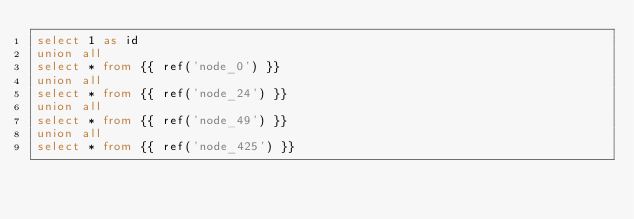Convert code to text. <code><loc_0><loc_0><loc_500><loc_500><_SQL_>select 1 as id
union all
select * from {{ ref('node_0') }}
union all
select * from {{ ref('node_24') }}
union all
select * from {{ ref('node_49') }}
union all
select * from {{ ref('node_425') }}</code> 